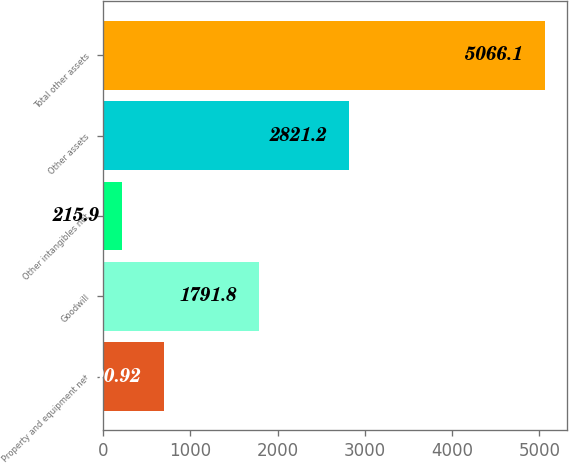Convert chart to OTSL. <chart><loc_0><loc_0><loc_500><loc_500><bar_chart><fcel>Property and equipment net<fcel>Goodwill<fcel>Other intangibles net<fcel>Other assets<fcel>Total other assets<nl><fcel>700.92<fcel>1791.8<fcel>215.9<fcel>2821.2<fcel>5066.1<nl></chart> 